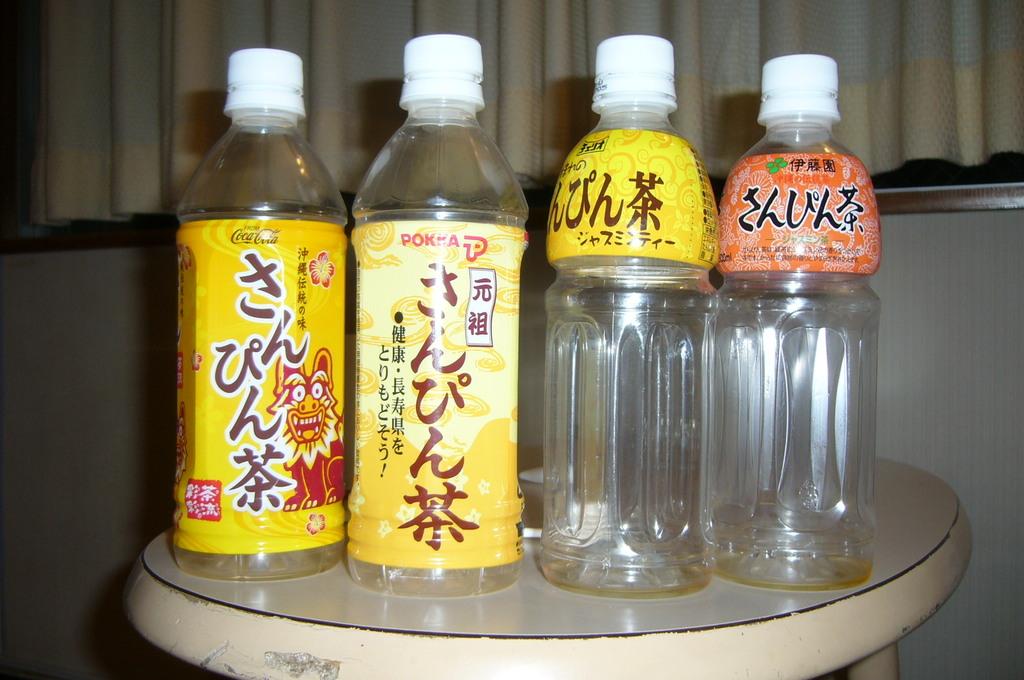What is the word in red on the 2nd bottle?
Keep it short and to the point. Pokka. 